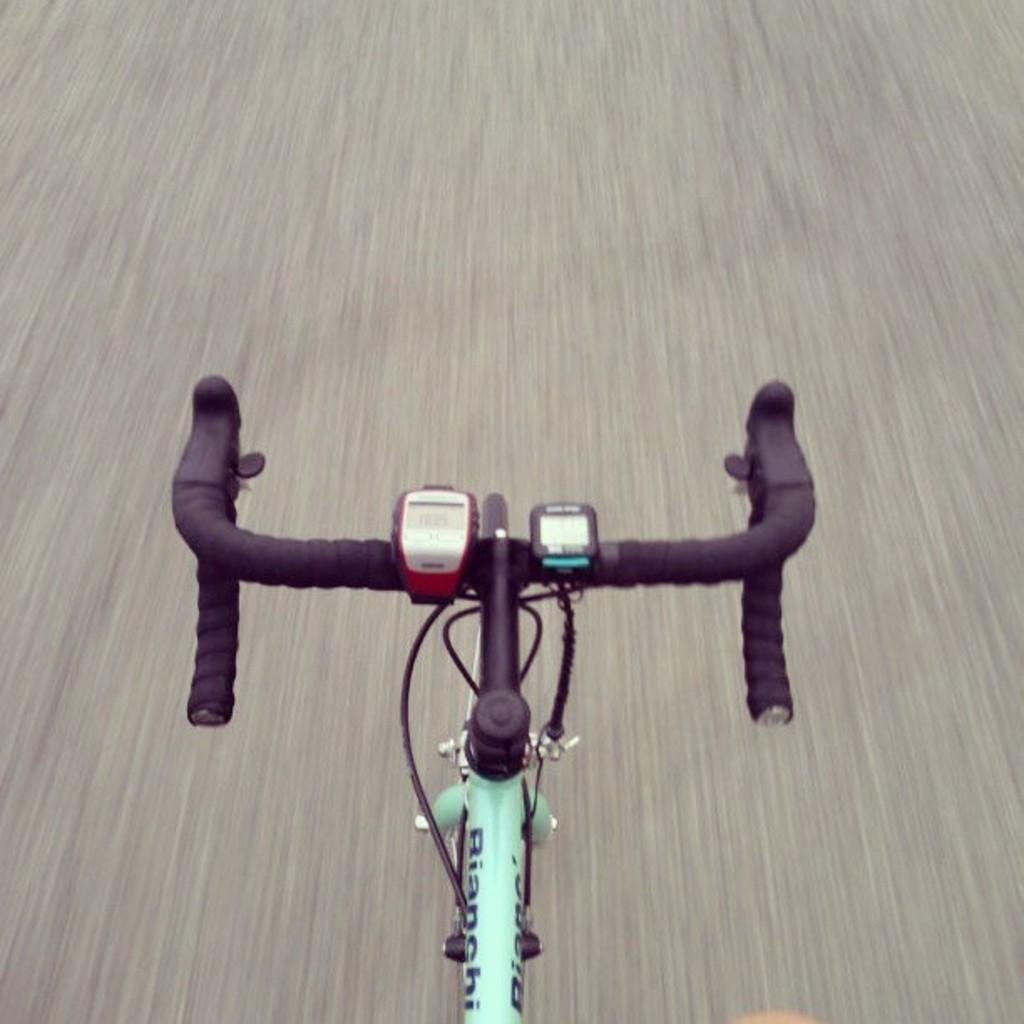In one or two sentences, can you explain what this image depicts? In this picture we can see a handlebar and a supporting rod of a bicycle, at the bottom there is road, there are two digital displays attached to the handle. 